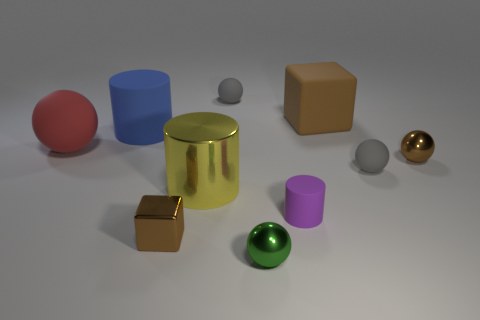How many spheres are either brown rubber objects or small purple objects?
Offer a terse response. 0. There is a metal thing that is the same size as the brown matte block; what is its color?
Your answer should be very brief. Yellow. What number of tiny gray rubber things are both in front of the large blue object and on the left side of the purple cylinder?
Ensure brevity in your answer.  0. What is the material of the tiny green object?
Make the answer very short. Metal. What number of objects are either small green things or large green cylinders?
Your answer should be compact. 1. There is a gray thing in front of the blue cylinder; is its size the same as the block in front of the tiny purple rubber cylinder?
Your response must be concise. Yes. What number of other objects are there of the same size as the yellow metallic object?
Give a very brief answer. 3. What number of things are either tiny brown objects to the right of the brown matte object or small rubber objects that are in front of the brown matte thing?
Your answer should be compact. 3. Is the yellow cylinder made of the same material as the brown thing behind the red object?
Ensure brevity in your answer.  No. What number of other things are the same shape as the tiny green shiny thing?
Ensure brevity in your answer.  4. 